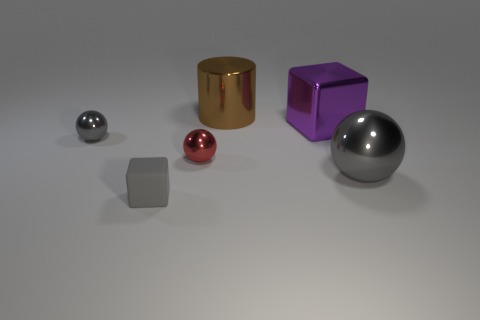Could you explain the composition of this image in terms of visual balance? The composition of this image is quite balanced in terms of visual weight and symmetry. The objects are arranged in a semi-arc formation, which creates a stable and harmonious structure. The varied sizes and spacing between the objects contribute to a pleasant distribution across the image. Despite the differences in size and color, no single object dominates the scene; rather, they complement each other to achieve an overall equilibrium.  If this were an artwork, what might it be trying to convey? If this image was an artwork, it might be attempting to convey the beauty and simplicity found in geometric shapes and the various textures and materials they can possess. Each object, with its distinct material properties and reflective qualities, could represent the diversity and unity among forms. There could also be a message about industrial design, where function and form come together in a simple yet visually engaging array. 